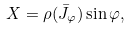Convert formula to latex. <formula><loc_0><loc_0><loc_500><loc_500>X = \rho ( \bar { J } _ { \varphi } ) \sin \varphi ,</formula> 